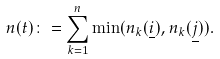<formula> <loc_0><loc_0><loc_500><loc_500>n ( t ) \colon = \sum _ { k = 1 } ^ { n } \min ( n _ { k } ( \underline { i } ) , n _ { k } ( \underline { j } ) ) .</formula> 